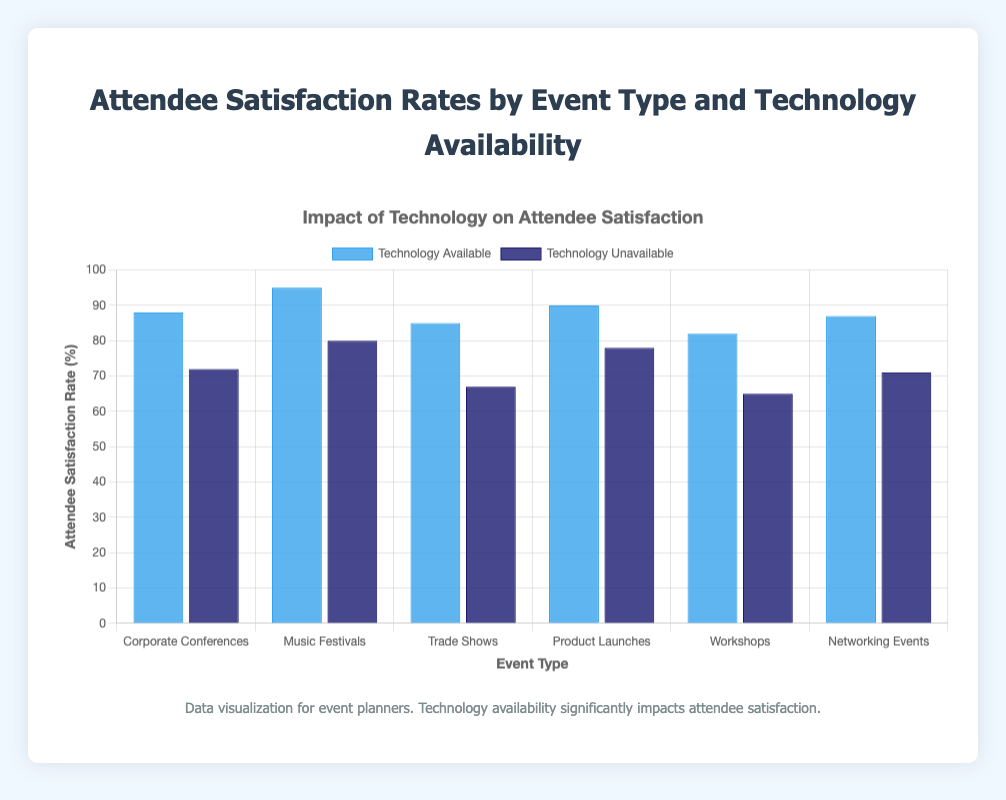Which event type shows the highest attendee satisfaction rate when technology is unavailable? To find the highest attendee satisfaction rate when technology is unavailable, look at the dark blue bars for each event type and identify the highest value. The highest satisfaction rate is 80, which belongs to Music Festivals.
Answer: Music Festivals What is the difference in attendee satisfaction rates for Corporate Conferences when technology is available versus unavailable? Look at the Corporate Conferences bars: 88 for technology available (lighter blue) and 72 for technology unavailable (darker blue). The difference is calculated as 88 - 72.
Answer: 16 On average, how much does technology availability increase the attendee satisfaction rate across all event types? Compute the differences for each event type, then find their average. The differences are 16 (Corporate Conferences), 15 (Music Festivals), 18 (Trade Shows), 12 (Product Launches), 17 (Workshops), and 16 (Networking Events). The average increase is (16 + 15 + 18 + 12 + 17 + 16) / 6.
Answer: 15.67 Which event type has the smallest gap in satisfaction rates between technology availability and unavailability? Calculate the differences for each event type: 16 (Corporate Conferences), 15 (Music Festivals), 18 (Trade Shows), 12 (Product Launches), 17 (Workshops), and 16 (Networking Events). The smallest gap is 12 for Product Launches.
Answer: Product Launches Which event type has the lowest attendee satisfaction rate when technology is available? Examine the light blue bars for each event type and identify the smallest value. The lowest satisfaction rate when technology is available is 82 for Workshops.
Answer: Workshops For which event type does technology unavailability impact attendee satisfaction the most negatively? Calculate the differences between satisfaction rates when technology is available and unavailable and identify the largest difference. The largest difference is 18 for Trade Shows (85 - 67).
Answer: Trade Shows What is the combined satisfaction rate for Music Festivals when technology is available and unavailable? Add the satisfaction rates for Music Festivals, 95 (available) and 80 (unavailable): 95 + 80.
Answer: 175 Are there any event types where the satisfaction rate is below 70 for unavailable technology? Check the dark blue bars for each event type to see if any values are below 70. Two types have satisfaction rates below 70: Trade Shows (67) and Workshops (65).
Answer: Yes What is the sum of satisfaction rates for all event types when technology is available? Add the lighter blue bars' values: 88 + 95 + 85 + 90 + 82 + 87.
Answer: 527 Is attendee satisfaction higher for Networking Events with technology available or Trade Shows with technology unavailable? Compare the satisfaction rates: Networking Events with technology available (87) vs. Trade Shows with technology unavailable (67). 87 is higher.
Answer: Networking Events with technology available 